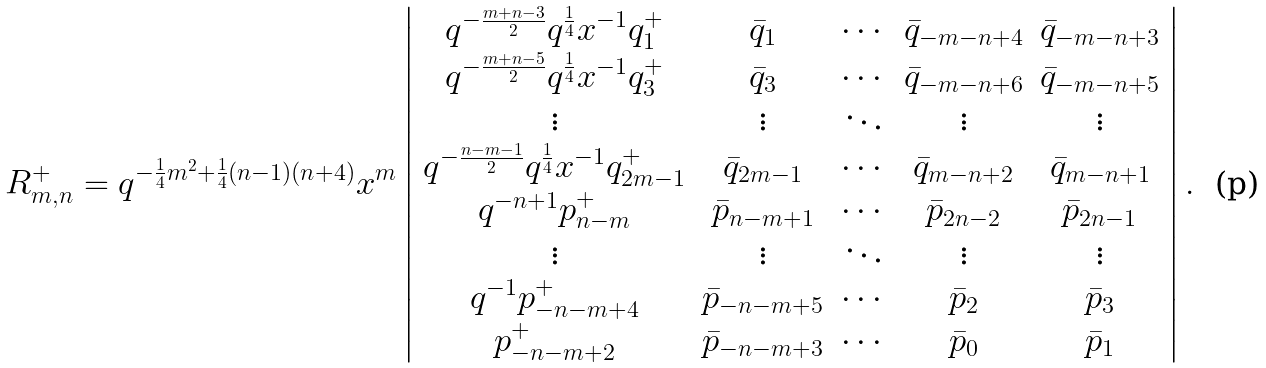<formula> <loc_0><loc_0><loc_500><loc_500>R _ { m , n } ^ { + } = q ^ { - \frac { 1 } { 4 } m ^ { 2 } + \frac { 1 } { 4 } ( n - 1 ) ( n + 4 ) } x ^ { m } \left | \begin{array} { c c c c c } q ^ { - \frac { m + n - 3 } { 2 } } q ^ { \frac { 1 } { 4 } } x ^ { - 1 } q _ { 1 } ^ { + } & \bar { q } _ { 1 } & \cdots & \bar { q } _ { - m - n + 4 } & \bar { q } _ { - m - n + 3 } \\ q ^ { - \frac { m + n - 5 } { 2 } } q ^ { \frac { 1 } { 4 } } x ^ { - 1 } q _ { 3 } ^ { + } & \bar { q } _ { 3 } & \cdots & \bar { q } _ { - m - n + 6 } & \bar { q } _ { - m - n + 5 } \\ \vdots & \vdots & \ddots & \vdots & \vdots \\ q ^ { - \frac { n - m - 1 } { 2 } } q ^ { \frac { 1 } { 4 } } x ^ { - 1 } q _ { 2 m - 1 } ^ { + } & \bar { q } _ { 2 m - 1 } & \cdots & \bar { q } _ { m - n + 2 } & \bar { q } _ { m - n + 1 } \\ q ^ { - n + 1 } p _ { n - m } ^ { + } & \bar { p } _ { n - m + 1 } & \cdots & \bar { p } _ { 2 n - 2 } & \bar { p } _ { 2 n - 1 } \\ \vdots & \vdots & \ddots & \vdots & \vdots \\ q ^ { - 1 } p _ { - n - m + 4 } ^ { + } & \bar { p } _ { - n - m + 5 } & \cdots & \bar { p } _ { 2 } & \bar { p } _ { 3 } \\ p _ { - n - m + 2 } ^ { + } & \bar { p } _ { - n - m + 3 } & \cdots & \bar { p } _ { 0 } & \bar { p } _ { 1 } \end{array} \right | .</formula> 